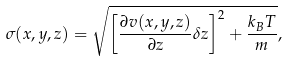<formula> <loc_0><loc_0><loc_500><loc_500>\sigma ( x , y , z ) = \sqrt { \left [ \frac { \partial v ( x , y , z ) } { \partial z } \delta z \right ] ^ { 2 } + \frac { k _ { B } T } { m } } ,</formula> 